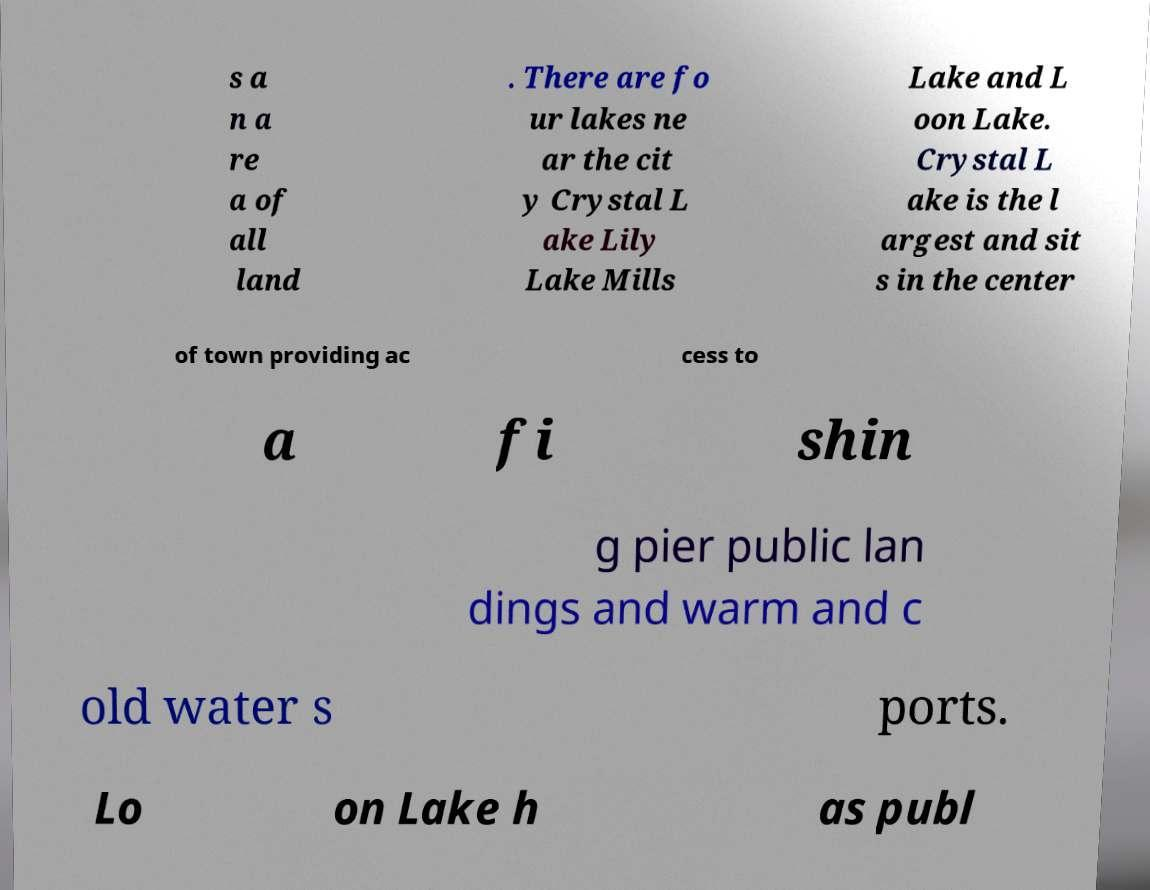What messages or text are displayed in this image? I need them in a readable, typed format. s a n a re a of all land . There are fo ur lakes ne ar the cit y Crystal L ake Lily Lake Mills Lake and L oon Lake. Crystal L ake is the l argest and sit s in the center of town providing ac cess to a fi shin g pier public lan dings and warm and c old water s ports. Lo on Lake h as publ 